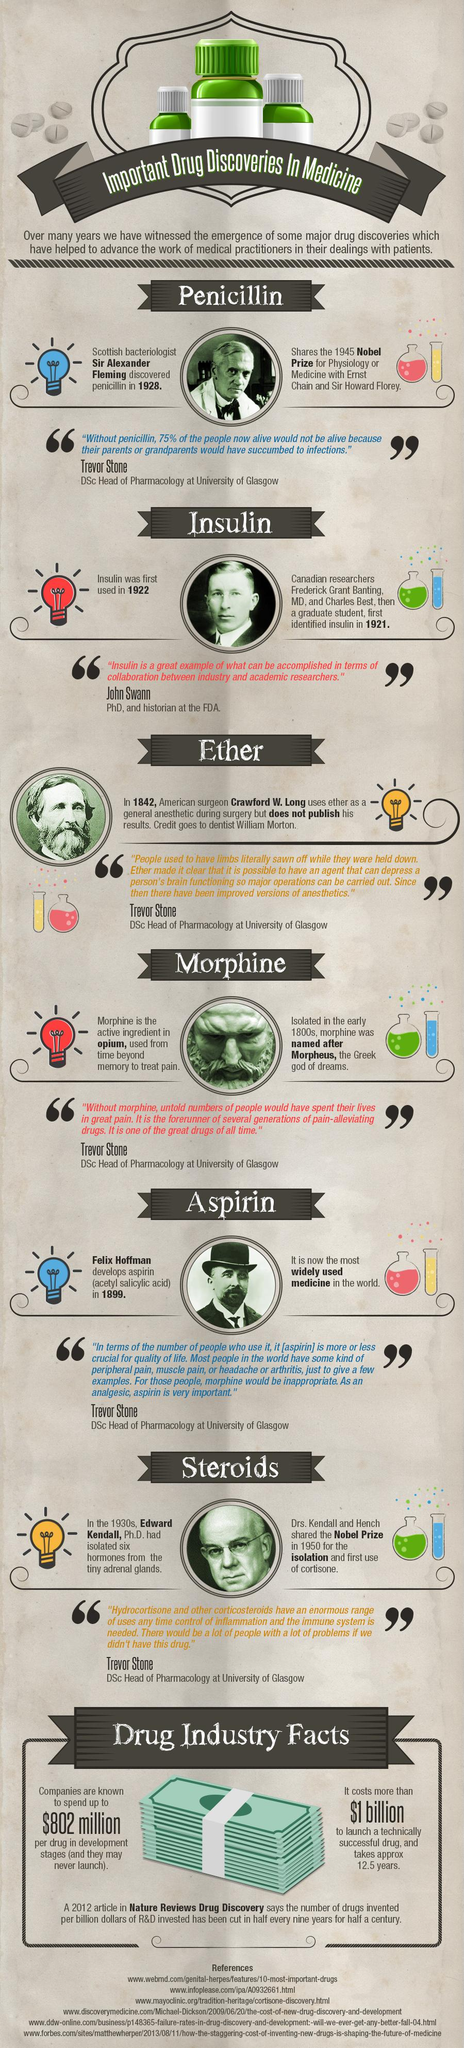Point out several critical features in this image. There are six drugs mentioned in this infographic. There are a total of two red bulbs depicted in this infographic. There are 6 test tubes depicted in this infographic. There are two blue bulbs depicted in this infographic. 